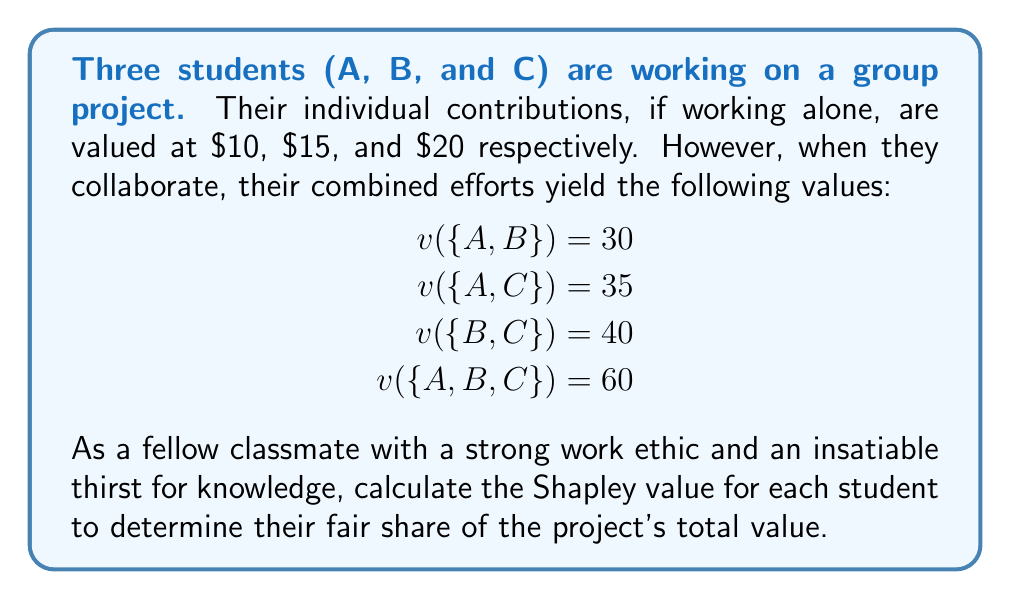Could you help me with this problem? To calculate the Shapley value, we need to consider all possible coalitions and the marginal contributions of each player. Let's follow these steps:

1) List all possible orderings of players:
   ABC, ACB, BAC, BCA, CAB, CBA

2) Calculate marginal contributions for each player in each ordering:

   ABC: A=10, B=20, C=30
   ACB: A=10, C=25, B=25
   BAC: B=15, A=15, C=30
   BCA: B=15, C=25, A=20
   CAB: C=20, A=15, B=25
   CBA: C=20, B=20, A=20

3) Sum up the marginal contributions for each player:

   A: 10 + 10 + 15 + 20 + 15 + 20 = 90
   B: 20 + 25 + 15 + 15 + 25 + 20 = 120
   C: 30 + 25 + 30 + 25 + 20 + 20 = 150

4) Divide each sum by the number of orderings (6) to get the Shapley value:

   Shapley value for A: $\frac{90}{6} = 15$
   Shapley value for B: $\frac{120}{6} = 20$
   Shapley value for C: $\frac{150}{6} = 25$

5) Verify that the sum of Shapley values equals the grand coalition value:

   $15 + 20 + 25 = 60 = v(\{A,B,C\})$

Therefore, the Shapley values represent a fair distribution of the total project value among the three students.
Answer: Shapley values: A=$15, B=$20, C=$25 